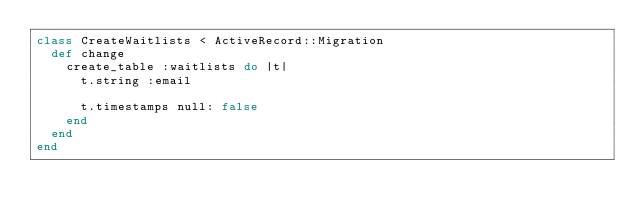Convert code to text. <code><loc_0><loc_0><loc_500><loc_500><_Ruby_>class CreateWaitlists < ActiveRecord::Migration
  def change
    create_table :waitlists do |t|
      t.string :email

      t.timestamps null: false
    end
  end
end
</code> 